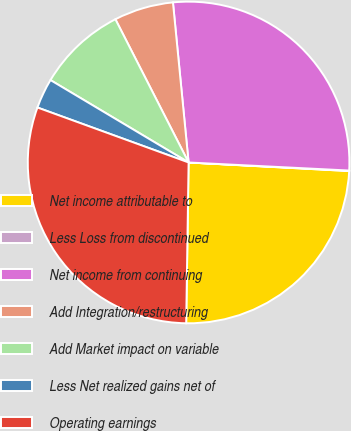<chart> <loc_0><loc_0><loc_500><loc_500><pie_chart><fcel>Net income attributable to<fcel>Less Loss from discontinued<fcel>Net income from continuing<fcel>Add Integration/restructuring<fcel>Add Market impact on variable<fcel>Less Net realized gains net of<fcel>Operating earnings<nl><fcel>24.39%<fcel>0.05%<fcel>27.35%<fcel>5.97%<fcel>8.92%<fcel>3.01%<fcel>30.31%<nl></chart> 